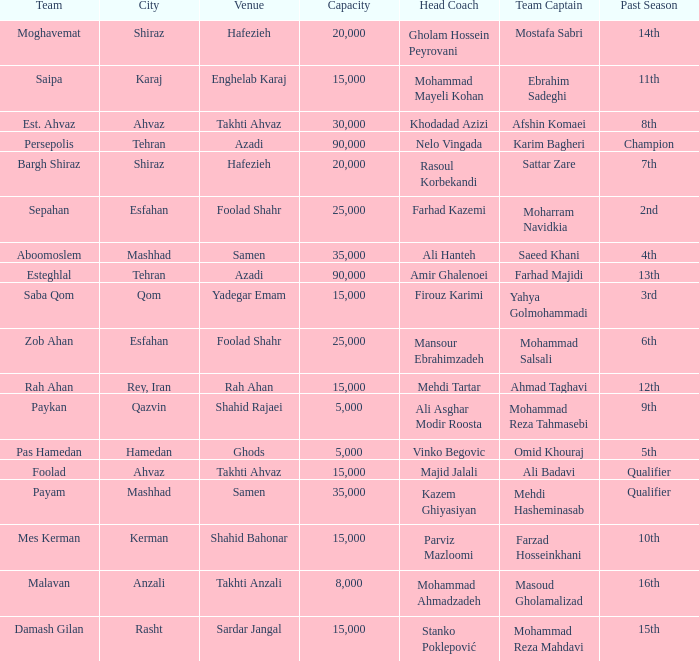What is the Capacity of the Venue of Head Coach Ali Asghar Modir Roosta? 5000.0. 